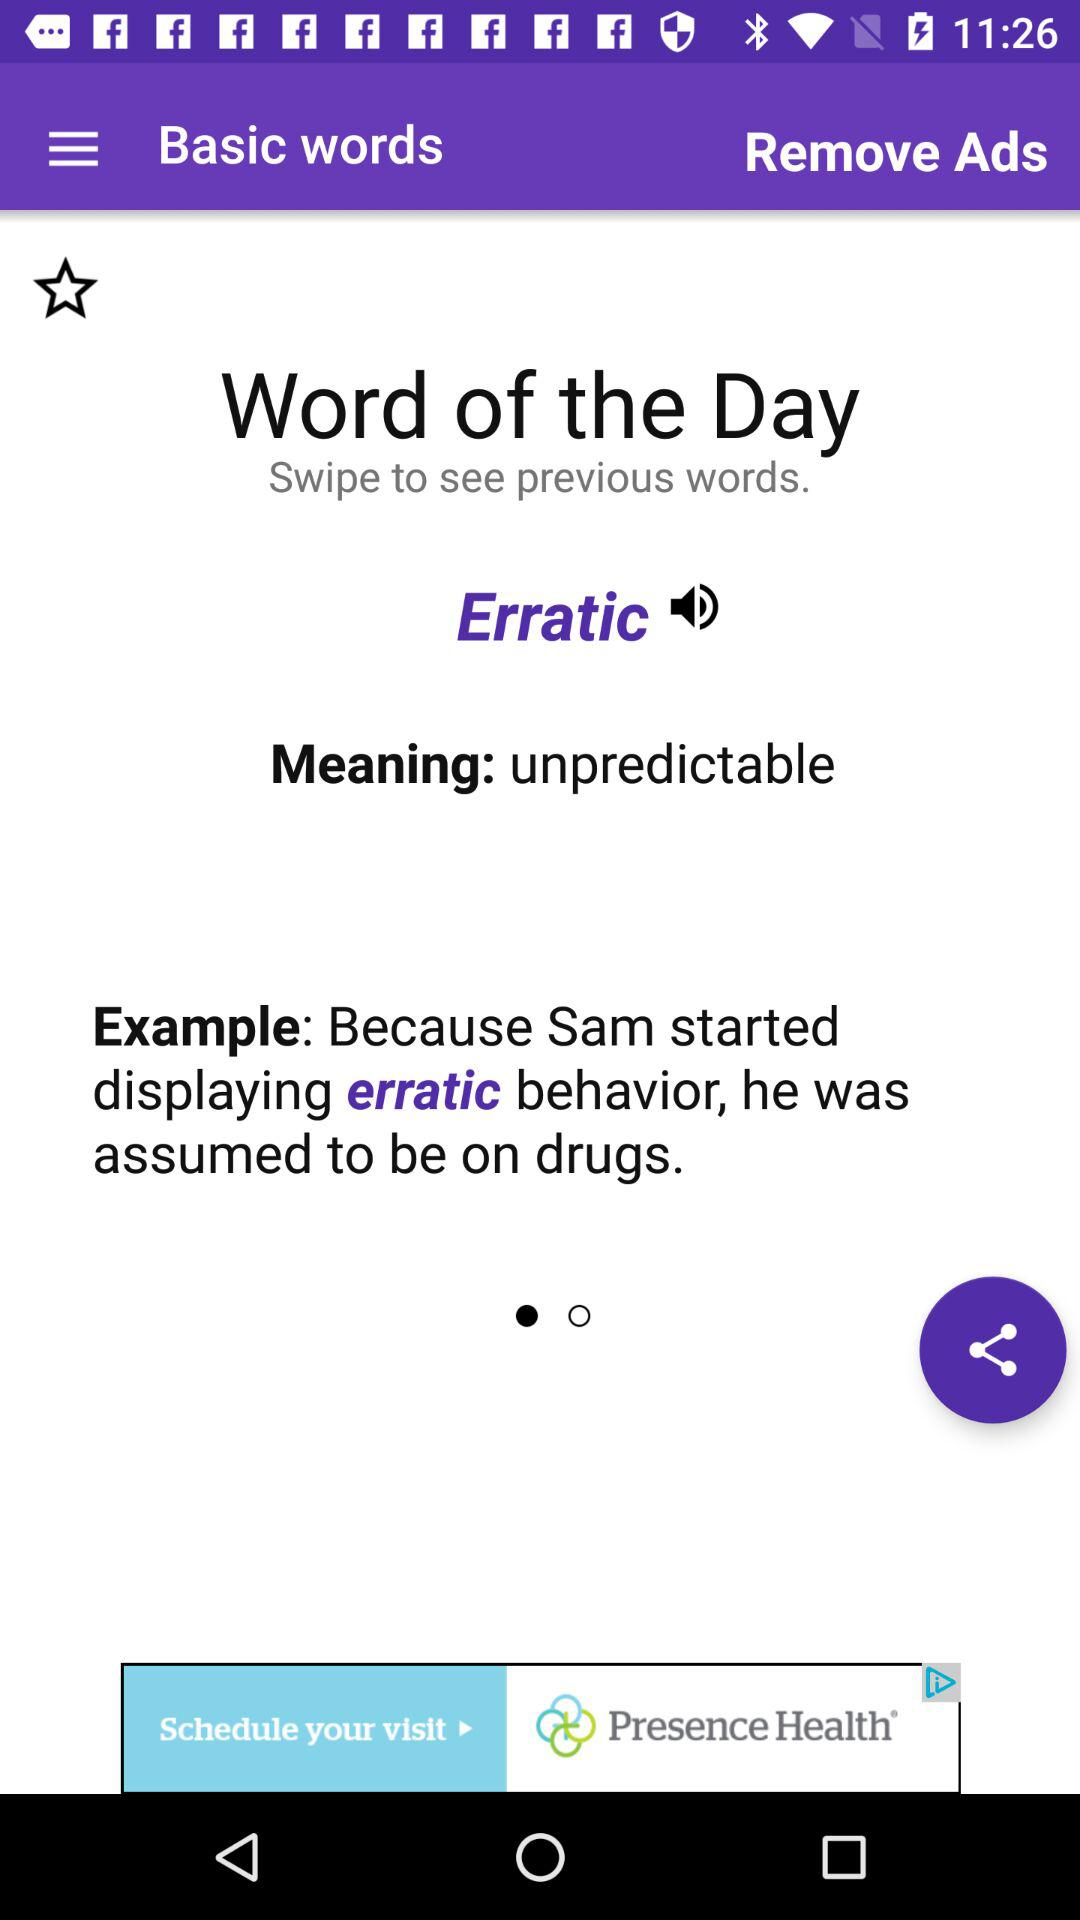What is the word of the day? The word of the day is "Erratic". 